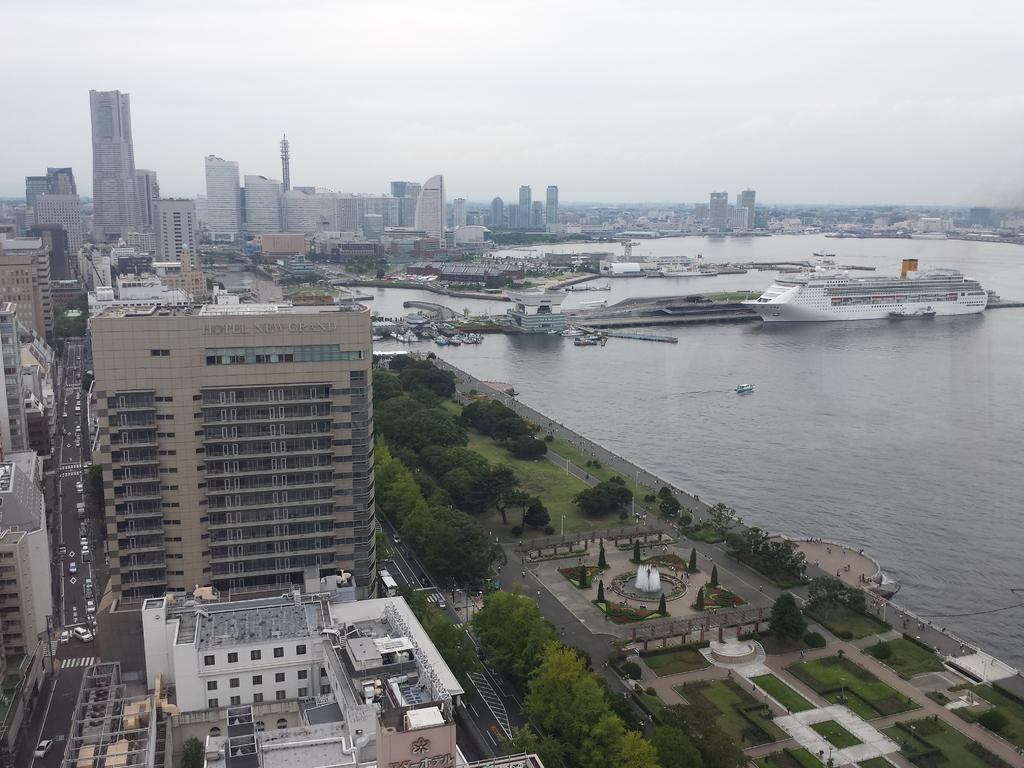What can be seen on the water in the image? There are ships on the ocean in the image. What type of structures are present in the image? There are buildings in the image. What type of transportation is visible on the road in the image? There are vehicles on the road in the image. What type of vegetation is present in the image? There are plants and trees in the image. What part of the natural environment is visible in the image? The sky is visible in the image. What type of yam is being harvested with a rake in the image? There is no yam or rake present in the image. What scent can be detected in the image? The image does not provide any information about scents, so it cannot be determined from the image. 